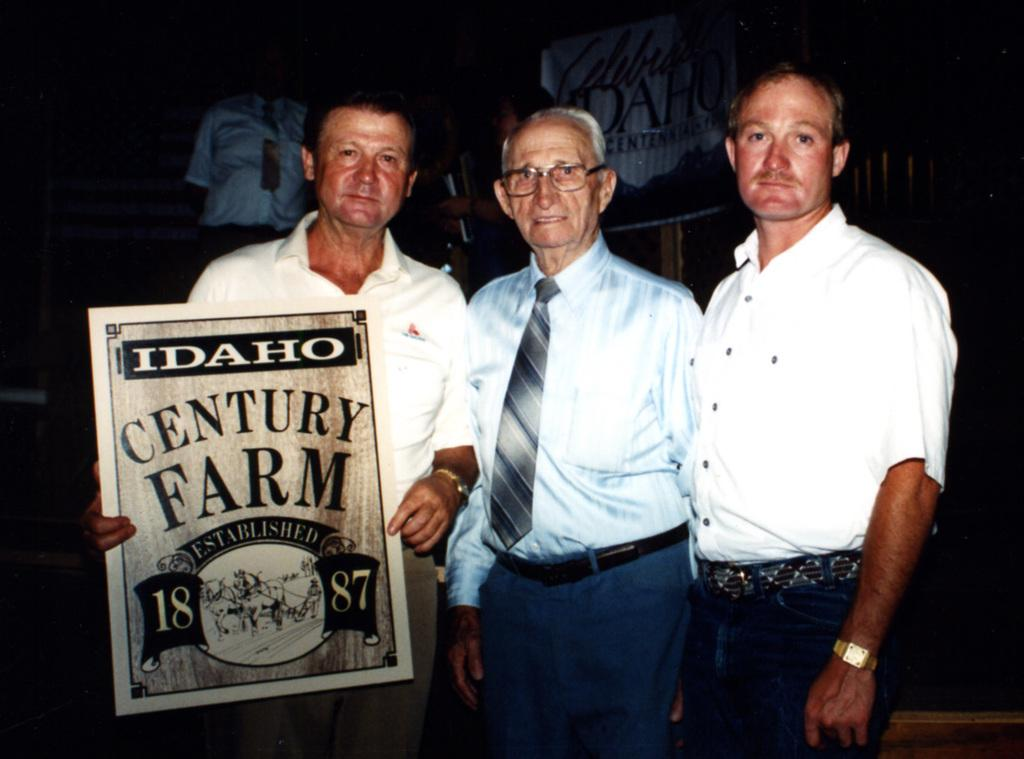What is happening in the image? There are people standing in the image, with one person holding a poster with text. Can you describe the poster being held by one of the people? The poster has text on it. What else can be seen in the image besides the people and the poster? There are additional people in the background. How would you describe the overall appearance of the image? The background of the image is dark. What type of branch can be seen in the image? There is no branch present in the image. How does the acoustics of the room affect the people's ability to hear the speaker in the image? There is no speaker or indication of acoustics in the image. What shape is the square in the image? There is no square present in the image. 